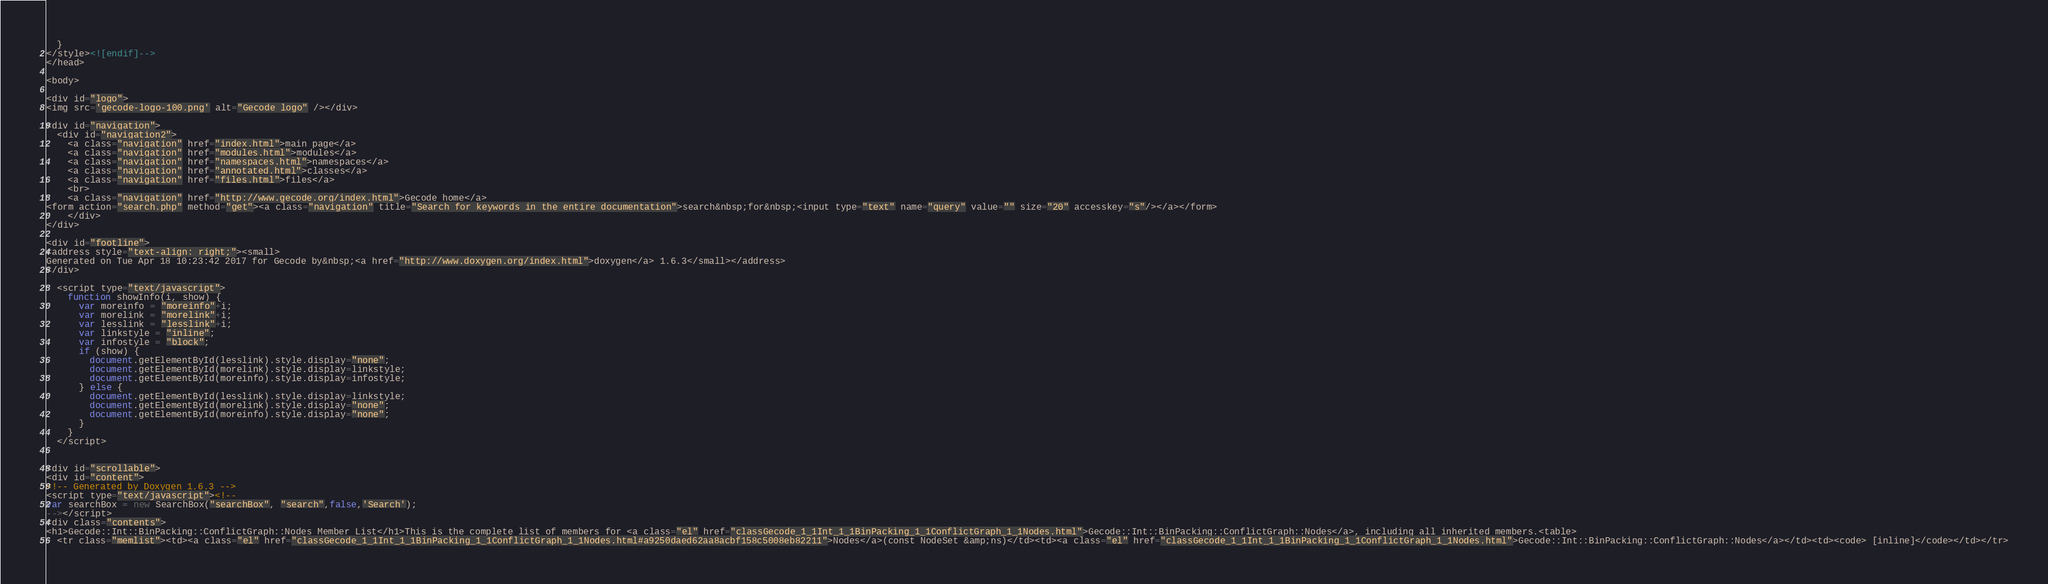Convert code to text. <code><loc_0><loc_0><loc_500><loc_500><_HTML_>  }
</style><![endif]-->
</head>

<body>

<div id="logo">
<img src='gecode-logo-100.png' alt="Gecode logo" /></div>

<div id="navigation">
  <div id="navigation2">
    <a class="navigation" href="index.html">main page</a>
    <a class="navigation" href="modules.html">modules</a>
    <a class="navigation" href="namespaces.html">namespaces</a>
    <a class="navigation" href="annotated.html">classes</a>
    <a class="navigation" href="files.html">files</a>
    <br>
    <a class="navigation" href="http://www.gecode.org/index.html">Gecode home</a>
<form action="search.php" method="get"><a class="navigation" title="Search for keywords in the entire documentation">search&nbsp;for&nbsp;<input type="text" name="query" value="" size="20" accesskey="s"/></a></form>
    </div>
</div>

<div id="footline">
<address style="text-align: right;"><small>
Generated on Tue Apr 18 10:23:42 2017 for Gecode by&nbsp;<a href="http://www.doxygen.org/index.html">doxygen</a> 1.6.3</small></address>
</div>

  <script type="text/javascript">
    function showInfo(i, show) {
      var moreinfo = "moreinfo"+i;
      var morelink = "morelink"+i;
      var lesslink = "lesslink"+i;
      var linkstyle = "inline";
      var infostyle = "block";
      if (show) {
        document.getElementById(lesslink).style.display="none";
        document.getElementById(morelink).style.display=linkstyle;
        document.getElementById(moreinfo).style.display=infostyle;
      } else {
        document.getElementById(lesslink).style.display=linkstyle;
        document.getElementById(morelink).style.display="none";
        document.getElementById(moreinfo).style.display="none";
      }
    }
  </script>


<div id="scrollable">
<div id="content">
<!-- Generated by Doxygen 1.6.3 -->
<script type="text/javascript"><!--
var searchBox = new SearchBox("searchBox", "search",false,'Search');
--></script>
<div class="contents">
<h1>Gecode::Int::BinPacking::ConflictGraph::Nodes Member List</h1>This is the complete list of members for <a class="el" href="classGecode_1_1Int_1_1BinPacking_1_1ConflictGraph_1_1Nodes.html">Gecode::Int::BinPacking::ConflictGraph::Nodes</a>, including all inherited members.<table>
  <tr class="memlist"><td><a class="el" href="classGecode_1_1Int_1_1BinPacking_1_1ConflictGraph_1_1Nodes.html#a9250daed62aa8acbf158c5008eb82211">Nodes</a>(const NodeSet &amp;ns)</td><td><a class="el" href="classGecode_1_1Int_1_1BinPacking_1_1ConflictGraph_1_1Nodes.html">Gecode::Int::BinPacking::ConflictGraph::Nodes</a></td><td><code> [inline]</code></td></tr></code> 